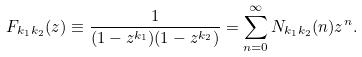<formula> <loc_0><loc_0><loc_500><loc_500>F _ { k _ { 1 } k _ { 2 } } ( z ) \equiv \frac { 1 } { ( 1 - z ^ { k _ { 1 } } ) ( 1 - z ^ { k _ { 2 } } ) } = \sum _ { n = 0 } ^ { \infty } N _ { k _ { 1 } k _ { 2 } } ( n ) z ^ { n } .</formula> 